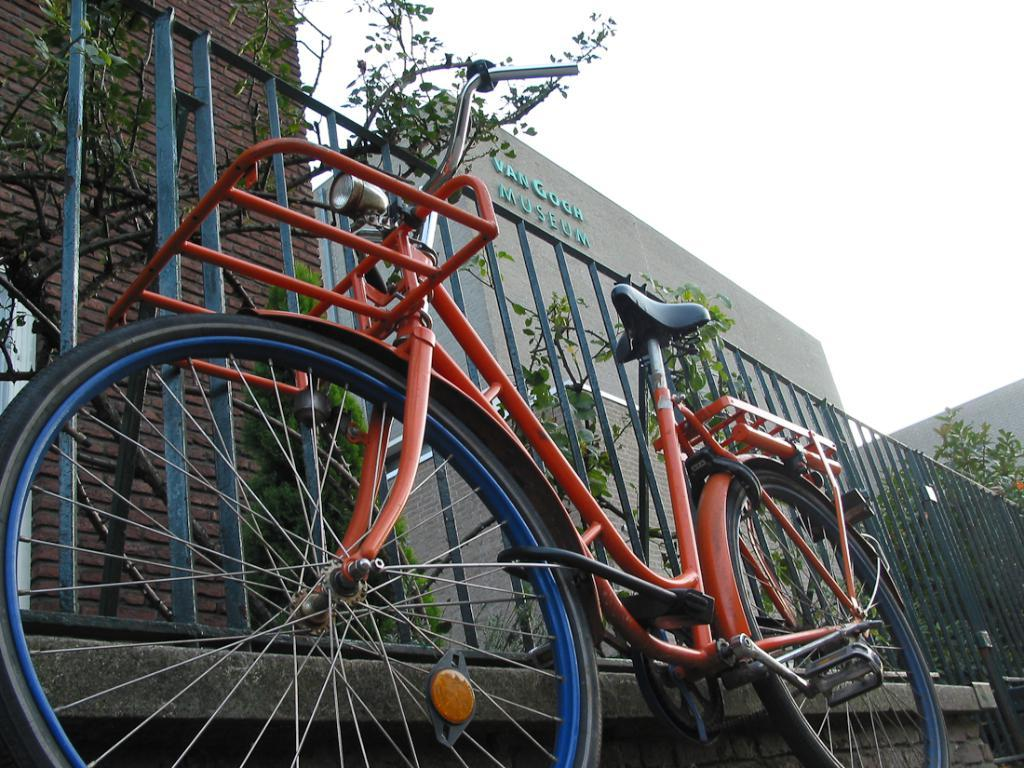What is the main object in the image? There is a bicycle in the image. What is located beside the bicycle? There is a fence beside the bicycle. What can be seen in the distance in the image? There are buildings, trees, and the sky visible in the background of the image. What type of feeling does the boot have in the image? There is no boot present in the image, so it is not possible to determine any feelings associated with it. 